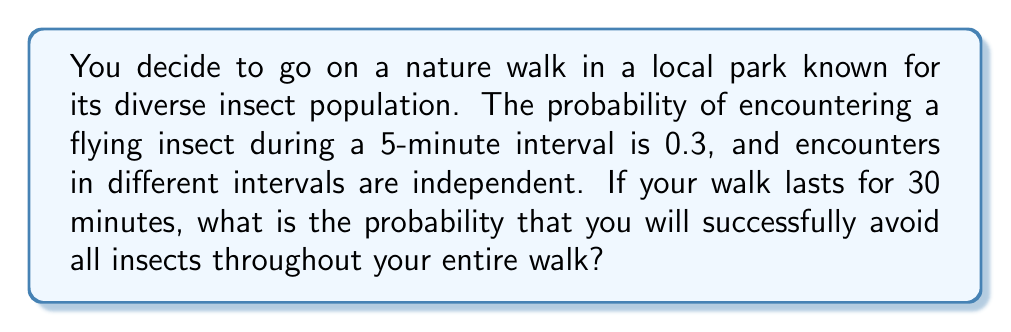What is the answer to this math problem? Let's approach this step-by-step:

1) First, we need to determine how many 5-minute intervals are in a 30-minute walk:
   $30 \div 5 = 6$ intervals

2) The probability of avoiding insects in one 5-minute interval is the complement of encountering them:
   $P(\text{avoiding in one interval}) = 1 - 0.3 = 0.7$

3) We want to avoid insects in all 6 intervals. Since the encounters are independent, we can use the multiplication rule of probability:

   $$P(\text{avoiding all}) = P(\text{avoiding in 1st}) \times P(\text{avoiding in 2nd}) \times ... \times P(\text{avoiding in 6th})$$

4) As the probability is the same for each interval:

   $$P(\text{avoiding all}) = 0.7 \times 0.7 \times 0.7 \times 0.7 \times 0.7 \times 0.7 = 0.7^6$$

5) Calculate:
   $$0.7^6 \approx 0.1176$$

6) Convert to percentage:
   $0.1176 \times 100\% \approx 11.76\%$
Answer: $11.76\%$ 